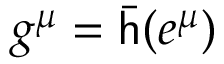<formula> <loc_0><loc_0><loc_500><loc_500>g ^ { \mu } = { \bar { h } } ( e ^ { \mu } )</formula> 